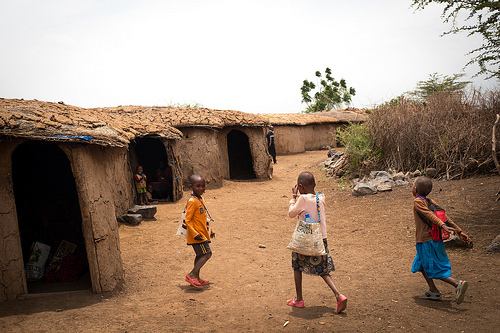<image>
Is the doorway behind the person? No. The doorway is not behind the person. From this viewpoint, the doorway appears to be positioned elsewhere in the scene. 